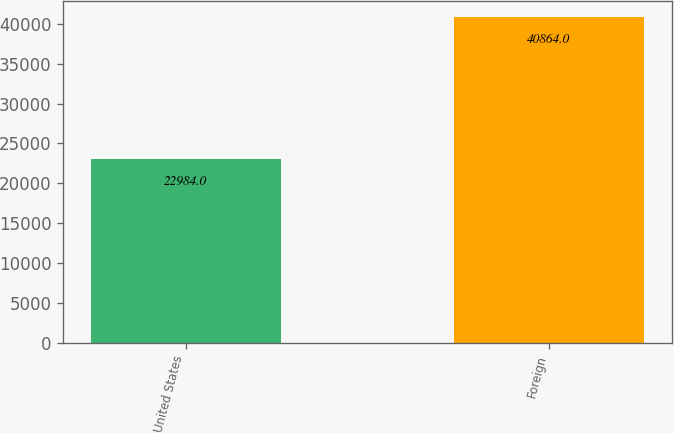Convert chart to OTSL. <chart><loc_0><loc_0><loc_500><loc_500><bar_chart><fcel>United States<fcel>Foreign<nl><fcel>22984<fcel>40864<nl></chart> 